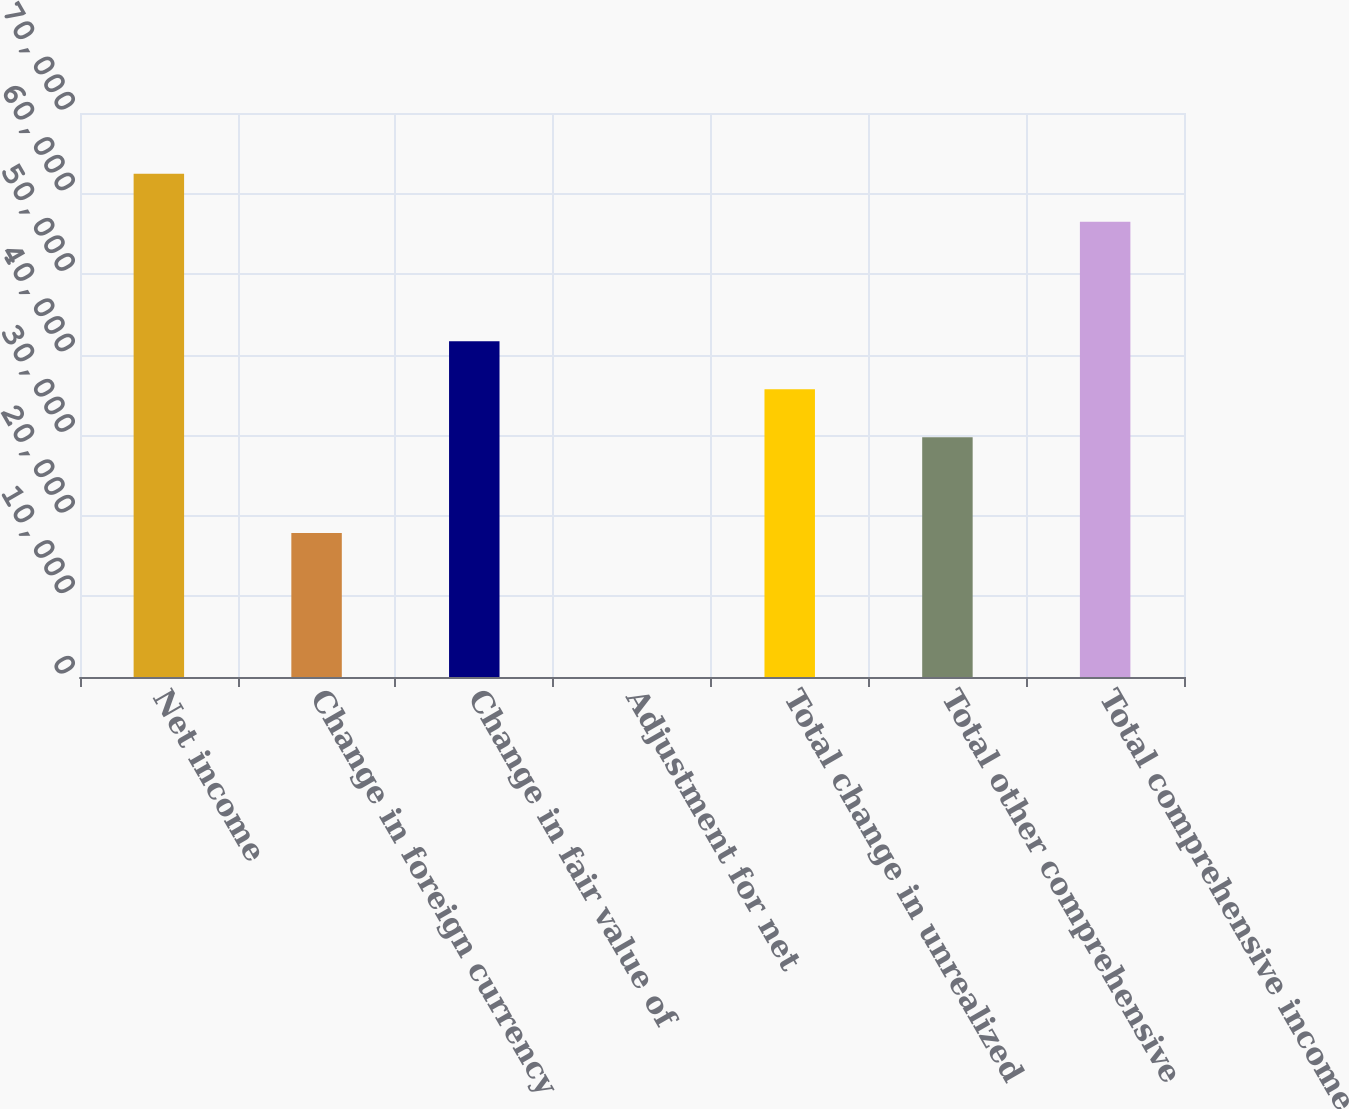Convert chart to OTSL. <chart><loc_0><loc_0><loc_500><loc_500><bar_chart><fcel>Net income<fcel>Change in foreign currency<fcel>Change in fair value of<fcel>Adjustment for net<fcel>Total change in unrealized<fcel>Total other comprehensive<fcel>Total comprehensive income<nl><fcel>62458<fcel>17860<fcel>41672<fcel>1<fcel>35719<fcel>29766<fcel>56505<nl></chart> 